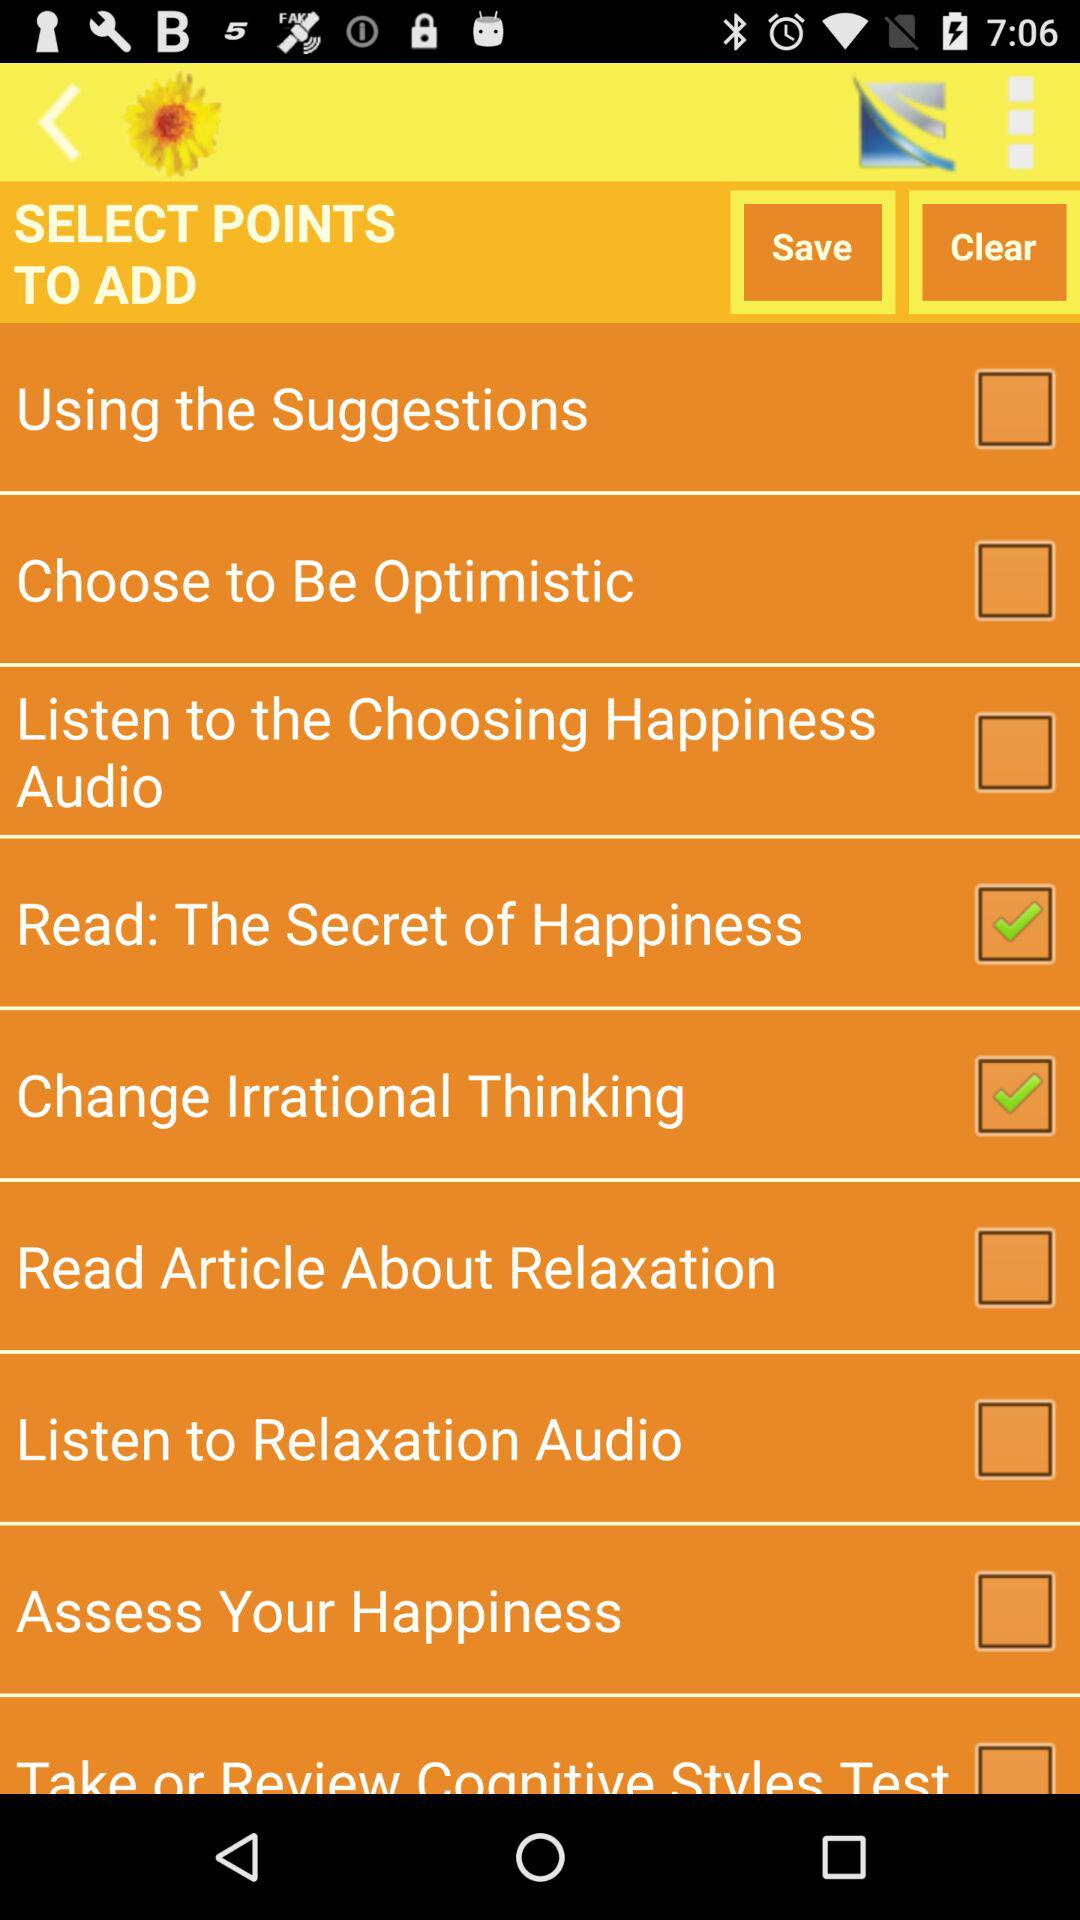What is the name of the selected checkbox points? The names of the selected checkbox points are "Read: The Secret of Happiness" and "Change Irrational Thinking". 